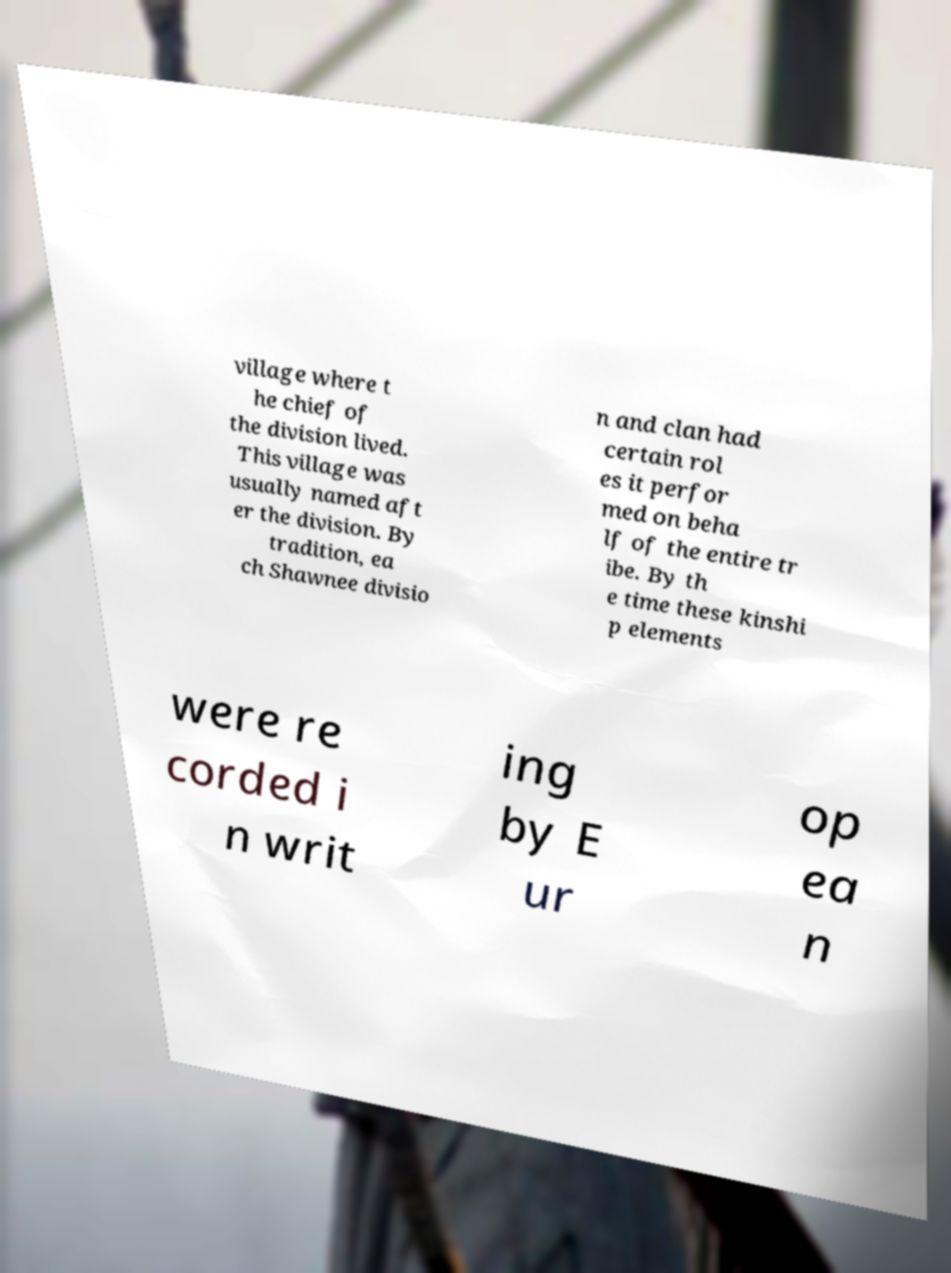Could you extract and type out the text from this image? village where t he chief of the division lived. This village was usually named aft er the division. By tradition, ea ch Shawnee divisio n and clan had certain rol es it perfor med on beha lf of the entire tr ibe. By th e time these kinshi p elements were re corded i n writ ing by E ur op ea n 